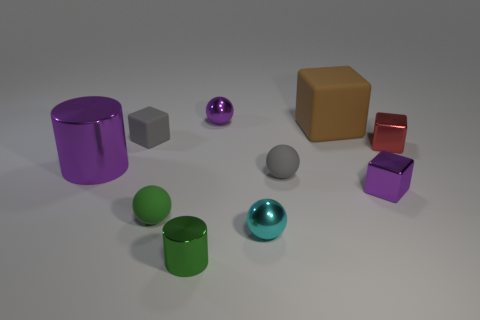Subtract all small rubber cubes. How many cubes are left? 3 Subtract 2 cubes. How many cubes are left? 2 Subtract all purple cylinders. How many cylinders are left? 1 Subtract all balls. How many objects are left? 6 Subtract 0 cyan cylinders. How many objects are left? 10 Subtract all brown cylinders. Subtract all green blocks. How many cylinders are left? 2 Subtract all purple cylinders. How many blue cubes are left? 0 Subtract all small blue rubber cylinders. Subtract all tiny rubber cubes. How many objects are left? 9 Add 4 red cubes. How many red cubes are left? 5 Add 9 green balls. How many green balls exist? 10 